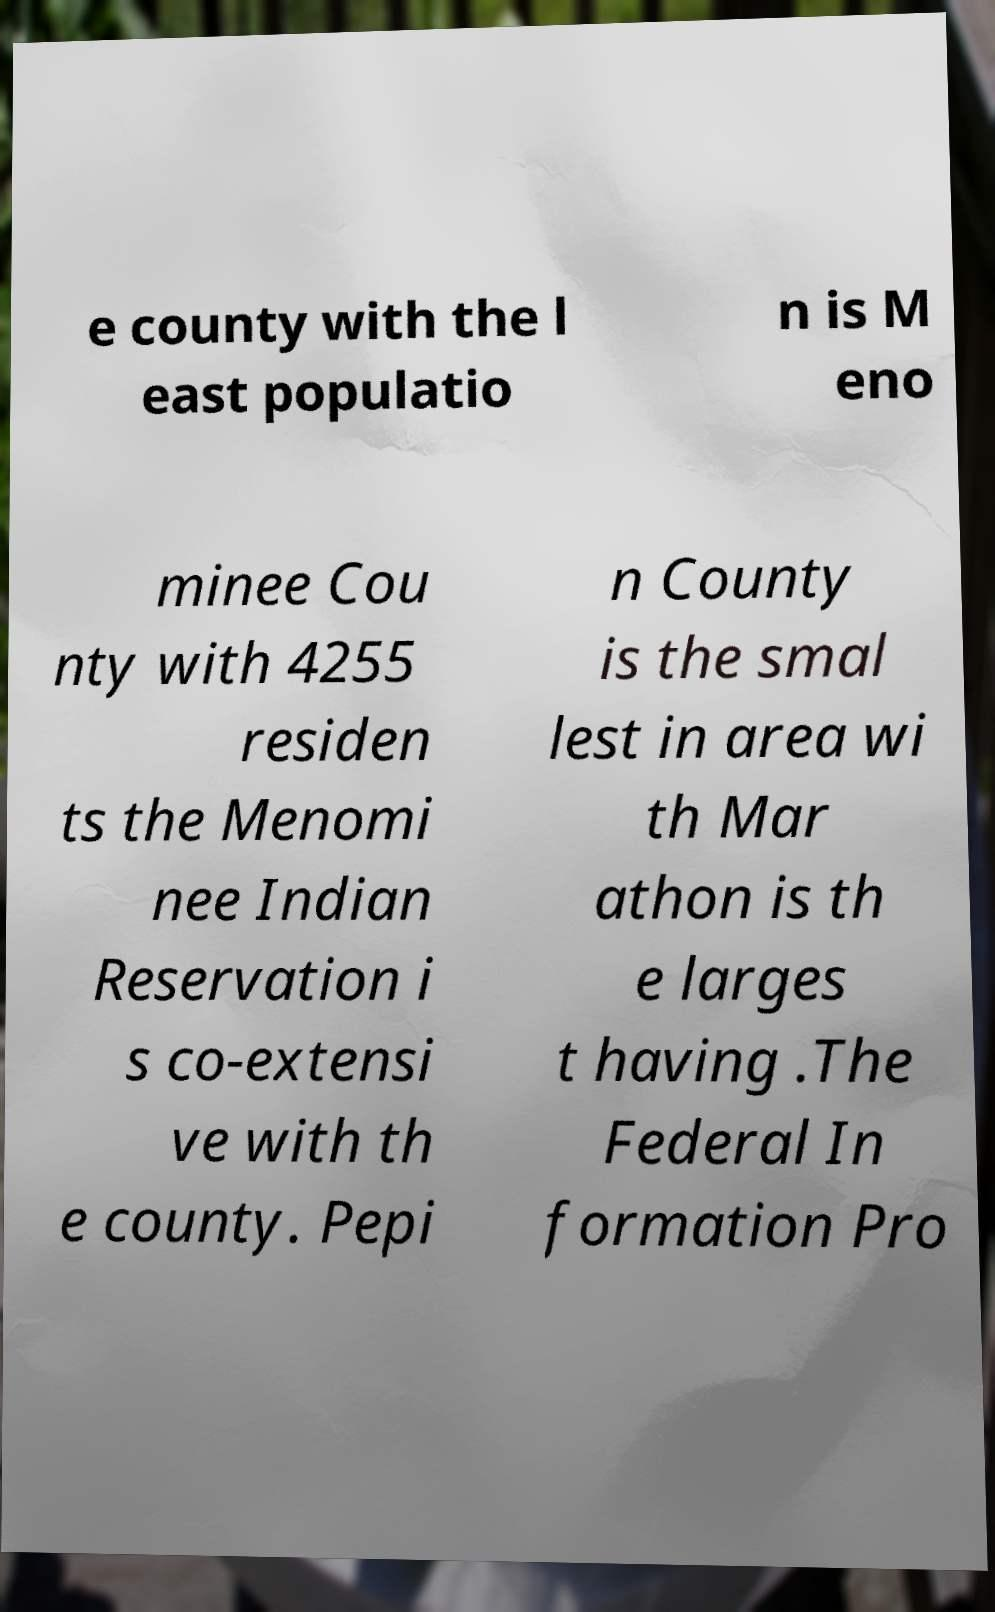Could you assist in decoding the text presented in this image and type it out clearly? e county with the l east populatio n is M eno minee Cou nty with 4255 residen ts the Menomi nee Indian Reservation i s co-extensi ve with th e county. Pepi n County is the smal lest in area wi th Mar athon is th e larges t having .The Federal In formation Pro 